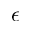<formula> <loc_0><loc_0><loc_500><loc_500>\epsilon</formula> 